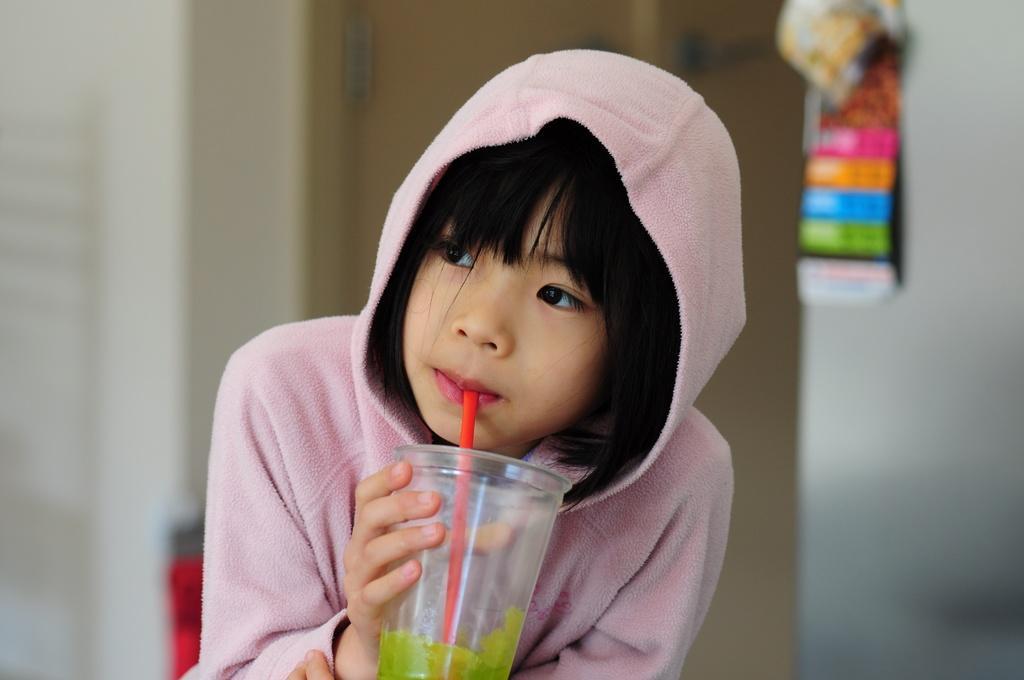How would you summarize this image in a sentence or two? In this image we can see a person a person and having some drink. There is an object on a wall. There is a door behind a person. 